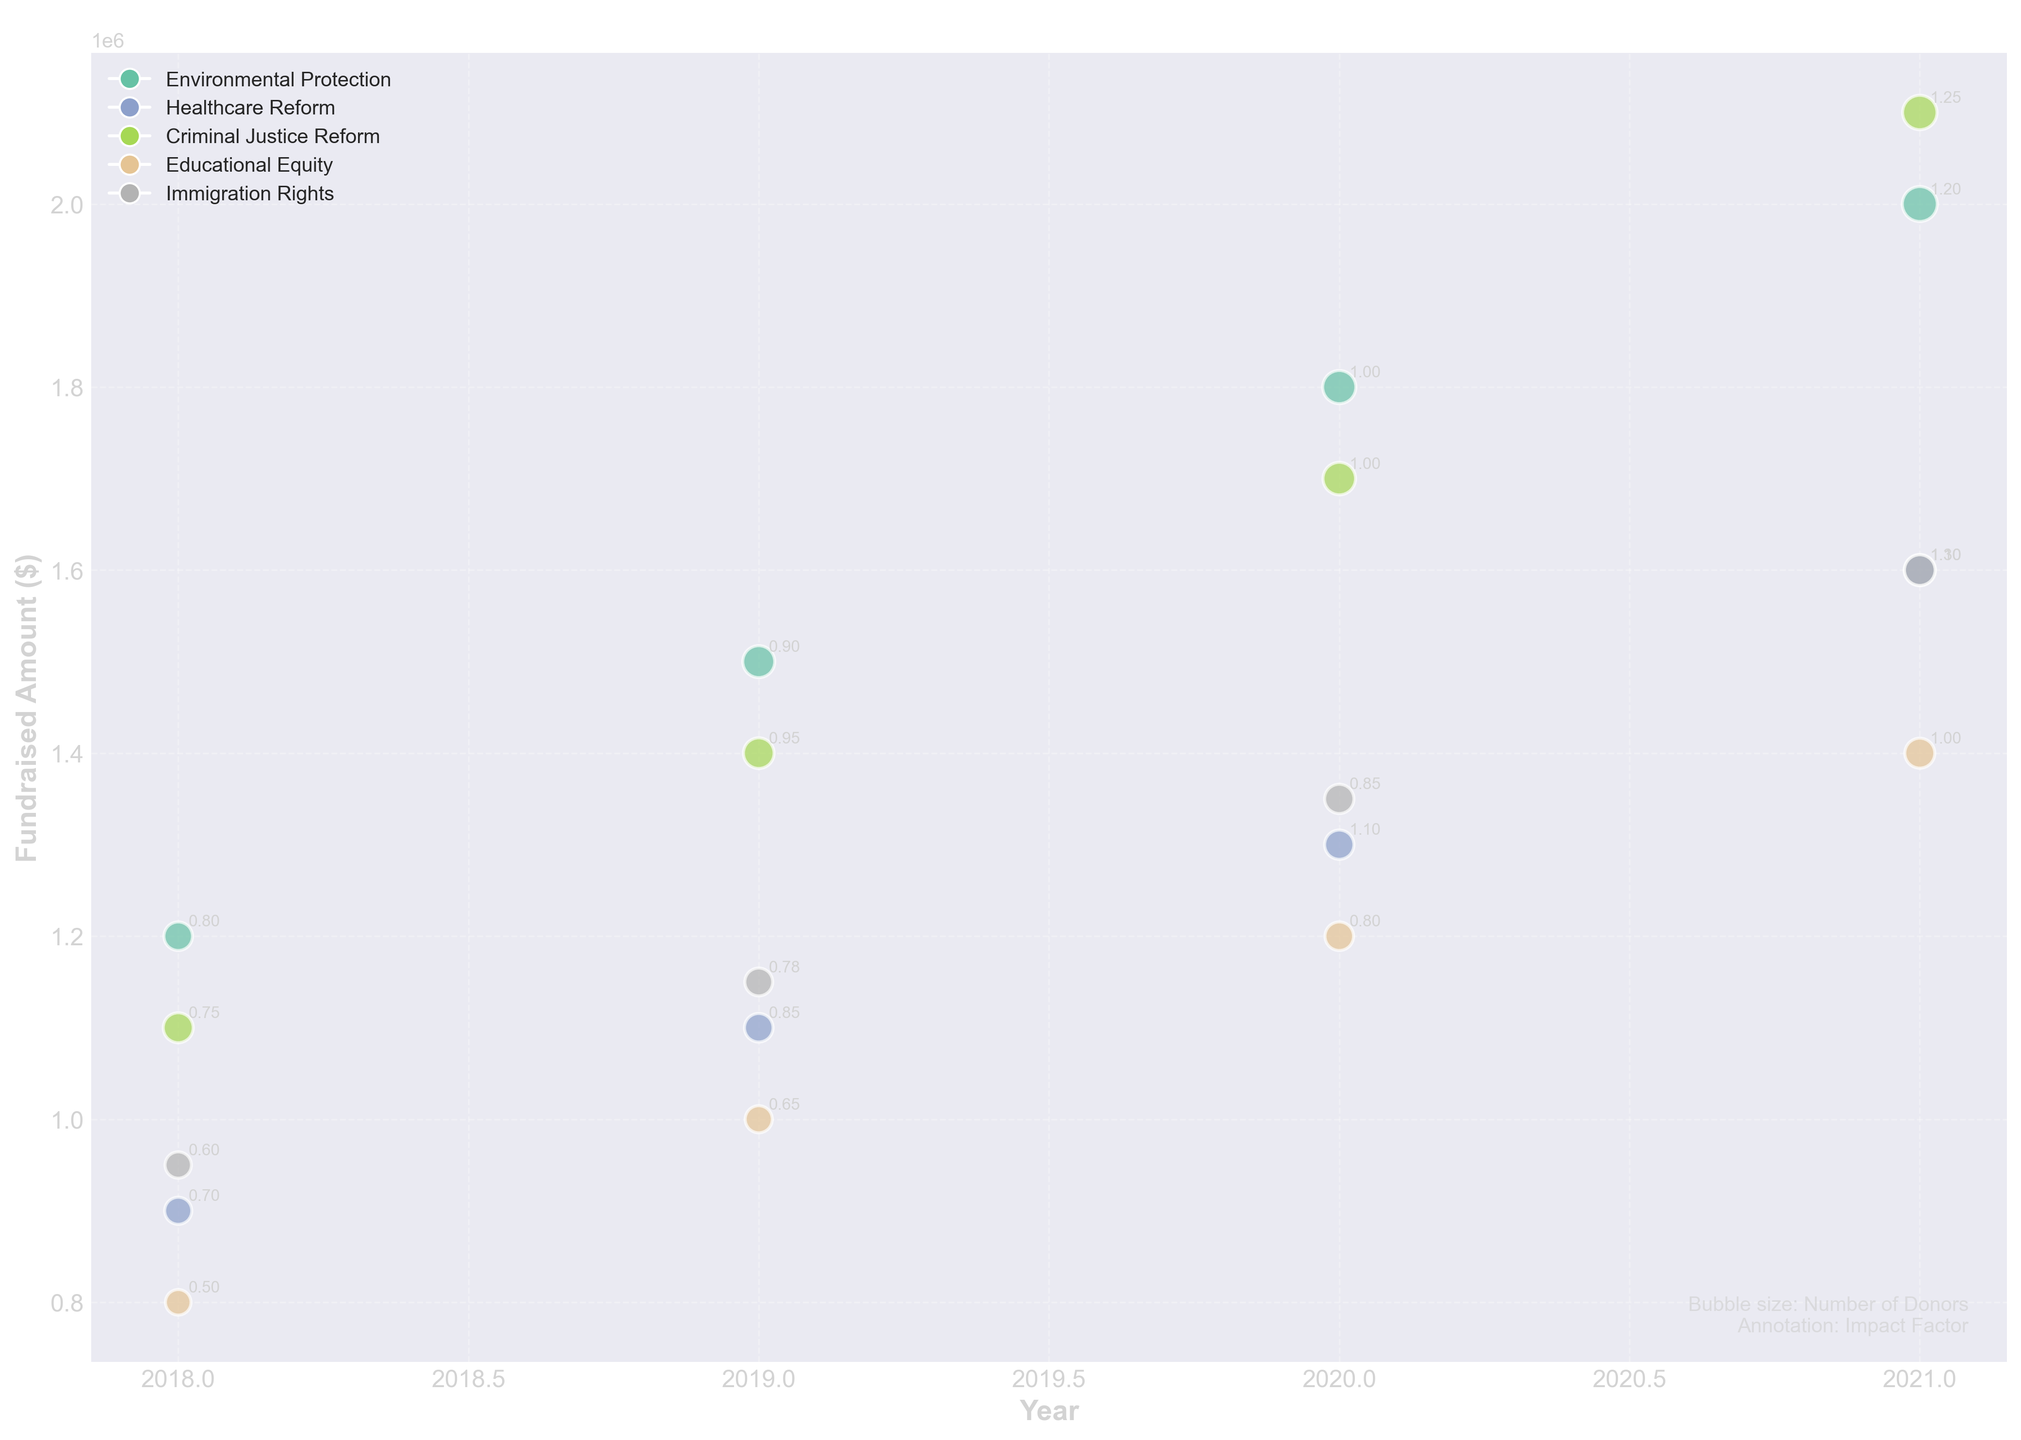What's the title of the figure? The title is generally found at the top of the figure in a larger and bolder font.
Answer: Fundraising Effectiveness Over Time What do the bubble sizes represent in the chart? According to the legend at the bottom left corner of the figure, the size of each bubble represents the Number of Donors.
Answer: Number of Donors Which campaign type had the highest fundraised amount in 2021? By examining the year 2021 on the x-axis and looking at the height of the bubbles, the highest y-value in that year represents the campaign with the highest fundraised amount.
Answer: Criminal Justice Reform How does the impact factor of the Environmental Protection campaign change over time? Look at the annotations within the bubbles for the Environmental Protection campaign from 2018 to 2021. The numbers inside the bubbles represent the impact factor.
Answer: It increases from 0.8 to 1.2 Which campaign had the most consistent growth in fundraised amount over the years? Consistent growth can be observed by looking at the trend of the bubbles along the years. The campaign with evenly spaced and continuously rising bubbles shows the most consistency.
Answer: Environmental Protection Compare the fundraised amounts between the Civil Lawsuit type campaigns for Environmental Protection and Educational Equity in 2020. Identify the year 2020 on the x-axis and compare the y-values (fundraised amounts) of the bubbles for Environmental Protection and Educational Equity campaigns that are marked with the same lawsuit type.
Answer: Environmental Protection raised 1800000 while Educational Equity raised 1200000 What's the average impact factor of campaigns that faced Regulatory Challenges in 2021? First, identify all bubbles marked as Regulatory Challenge in the year 2021 from the legend. Then, look at their annotations for the impact factor, sum those values and divide by the number of campaigns.
Answer: (1.3 + 1.1) / 2 = 1.2 Between 2018 and 2021, which campaign showed the largest increase in the number of donors? For each campaign, find the difference in the bubble size between 2018 and 2021. The campaign with the largest positive change in size has the largest increase in the number of donors.
Answer: Criminal Justice Reform Which campaign type has bubbles with the highest average impact factor? Calculate the average value of the impact factors (annotations inside bubbles) for each campaign type, and compare these averages.
Answer: Criminal Justice Reform 